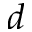<formula> <loc_0><loc_0><loc_500><loc_500>d</formula> 